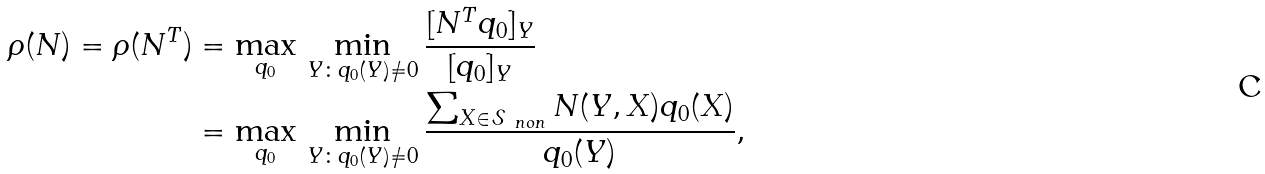Convert formula to latex. <formula><loc_0><loc_0><loc_500><loc_500>\rho ( N ) = \rho ( N ^ { T } ) & = \max _ { q _ { 0 } } \, \min _ { Y \colon q _ { 0 } ( Y ) \neq 0 } \frac { [ N ^ { T } q _ { 0 } ] _ { Y } } { [ q _ { 0 } ] _ { Y } } \\ & = \max _ { q _ { 0 } } \, \min _ { Y \colon q _ { 0 } ( Y ) \neq 0 } \frac { \sum _ { X \in \mathcal { S } _ { \ n o n } } N ( Y , X ) q _ { 0 } ( X ) } { q _ { 0 } ( Y ) } ,</formula> 